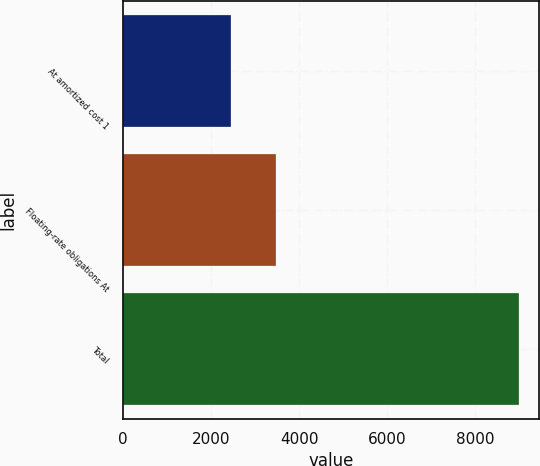<chart> <loc_0><loc_0><loc_500><loc_500><bar_chart><fcel>At amortized cost 1<fcel>Floating-rate obligations At<fcel>Total<nl><fcel>2452<fcel>3483<fcel>9005<nl></chart> 